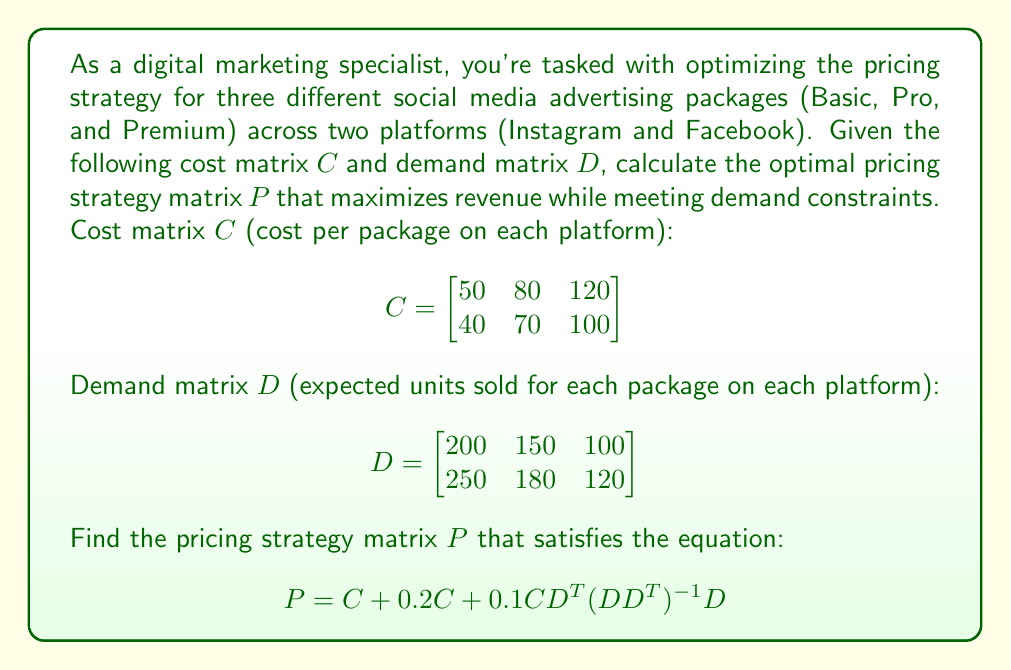Provide a solution to this math problem. To solve this problem, we'll follow these steps:

1) First, calculate $0.2C$:
   $$0.2C = \begin{bmatrix}
   10 & 16 & 24 \\
   8 & 14 & 20
   \end{bmatrix}$$

2) Calculate $D^T$:
   $$D^T = \begin{bmatrix}
   200 & 250 \\
   150 & 180 \\
   100 & 120
   \end{bmatrix}$$

3) Calculate $DD^T$:
   $$DD^T = \begin{bmatrix}
   200 & 150 & 100 \\
   250 & 180 & 120
   \end{bmatrix} \begin{bmatrix}
   200 & 250 \\
   150 & 180 \\
   100 & 120
   \end{bmatrix} = \begin{bmatrix}
   70000 & 86000 \\
   86000 & 106600
   \end{bmatrix}$$

4) Calculate $(DD^T)^{-1}$:
   $$(DD^T)^{-1} = \frac{1}{70000 \cdot 106600 - 86000^2} \begin{bmatrix}
   106600 & -86000 \\
   -86000 & 70000
   \end{bmatrix} = \begin{bmatrix}
   0.0000378 & -0.0000305 \\
   -0.0000305 & 0.0000248
   \end{bmatrix}$$

5) Calculate $CD^T$:
   $$CD^T = \begin{bmatrix}
   50 & 80 & 120 \\
   40 & 70 & 100
   \end{bmatrix} \begin{bmatrix}
   200 & 250 \\
   150 & 180 \\
   100 & 120
   \end{bmatrix} = \begin{bmatrix}
   34000 & 41600 \\
   28000 & 34300
   \end{bmatrix}$$

6) Calculate $0.1CD^T(DD^T)^{-1}D$:
   $$0.1CD^T(DD^T)^{-1}D = 0.1 \cdot \begin{bmatrix}
   34000 & 41600 \\
   28000 & 34300
   \end{bmatrix} \begin{bmatrix}
   0.0000378 & -0.0000305 \\
   -0.0000305 & 0.0000248
   \end{bmatrix} \begin{bmatrix}
   200 & 150 & 100 \\
   250 & 180 & 120
   \end{bmatrix}$$
   
   $$= \begin{bmatrix}
   5 & 8 & 12 \\
   4 & 7 & 10
   \end{bmatrix}$$

7) Finally, calculate $P = C + 0.2C + 0.1CD^T(DD^T)^{-1}D$:
   $$P = \begin{bmatrix}
   50 & 80 & 120 \\
   40 & 70 & 100
   \end{bmatrix} + \begin{bmatrix}
   10 & 16 & 24 \\
   8 & 14 & 20
   \end{bmatrix} + \begin{bmatrix}
   5 & 8 & 12 \\
   4 & 7 & 10
   \end{bmatrix}$$

   $$= \begin{bmatrix}
   65 & 104 & 156 \\
   52 & 91 & 130
   \end{bmatrix}$$
Answer: $$P = \begin{bmatrix}
65 & 104 & 156 \\
52 & 91 & 130
\end{bmatrix}$$ 